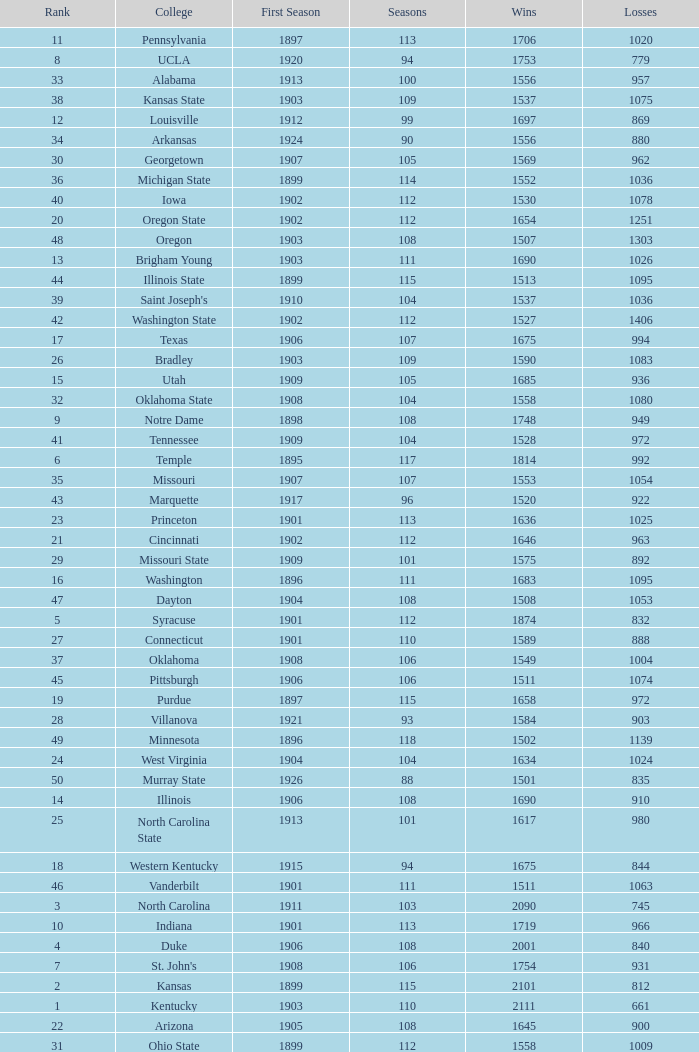How many wins were there for Washington State College with losses greater than 980 and a first season before 1906 and rank greater than 42? 0.0. 